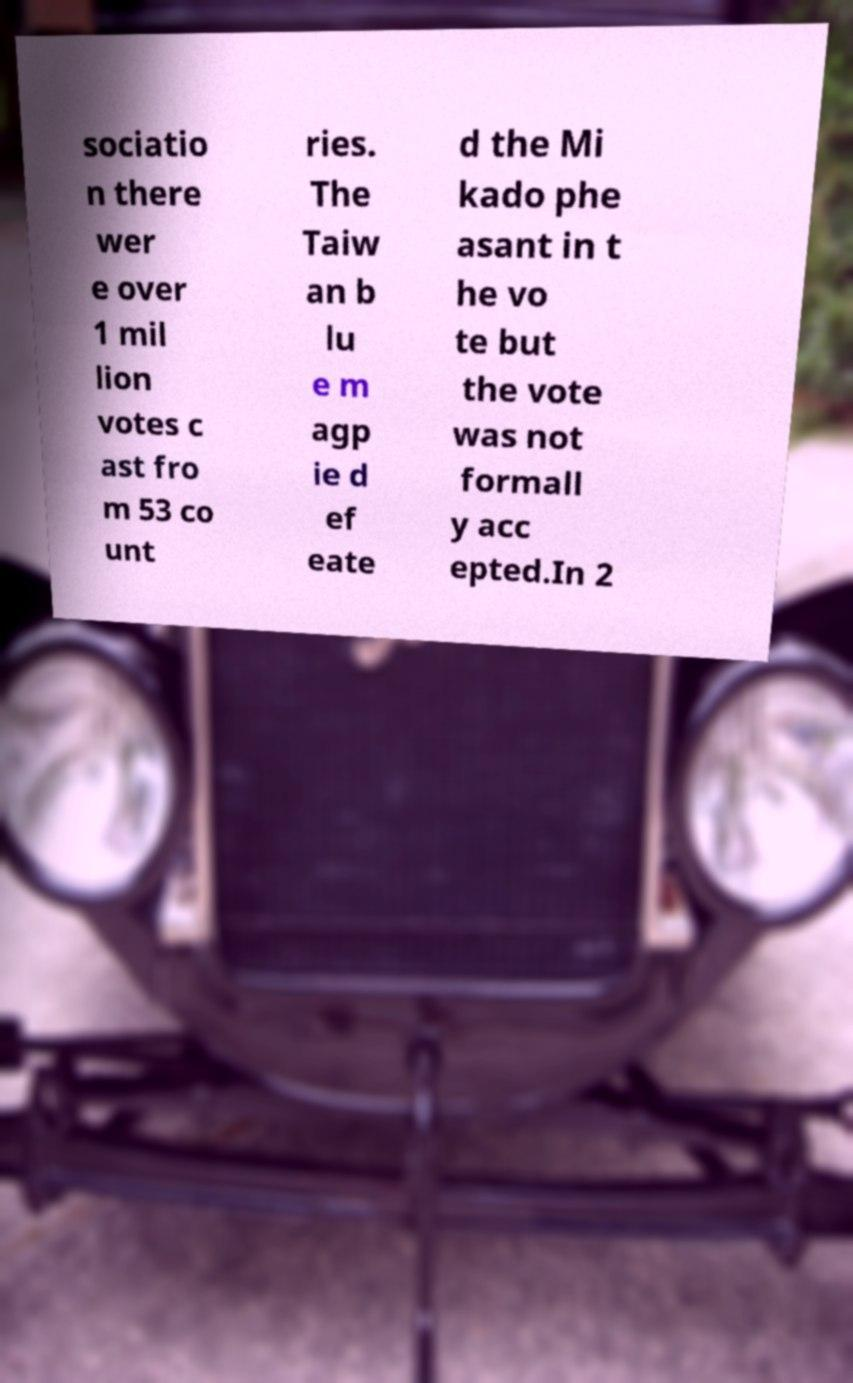What messages or text are displayed in this image? I need them in a readable, typed format. sociatio n there wer e over 1 mil lion votes c ast fro m 53 co unt ries. The Taiw an b lu e m agp ie d ef eate d the Mi kado phe asant in t he vo te but the vote was not formall y acc epted.In 2 